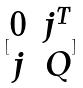<formula> <loc_0><loc_0><loc_500><loc_500>[ \begin{matrix} 0 & j ^ { T } \\ j & Q \end{matrix} ]</formula> 